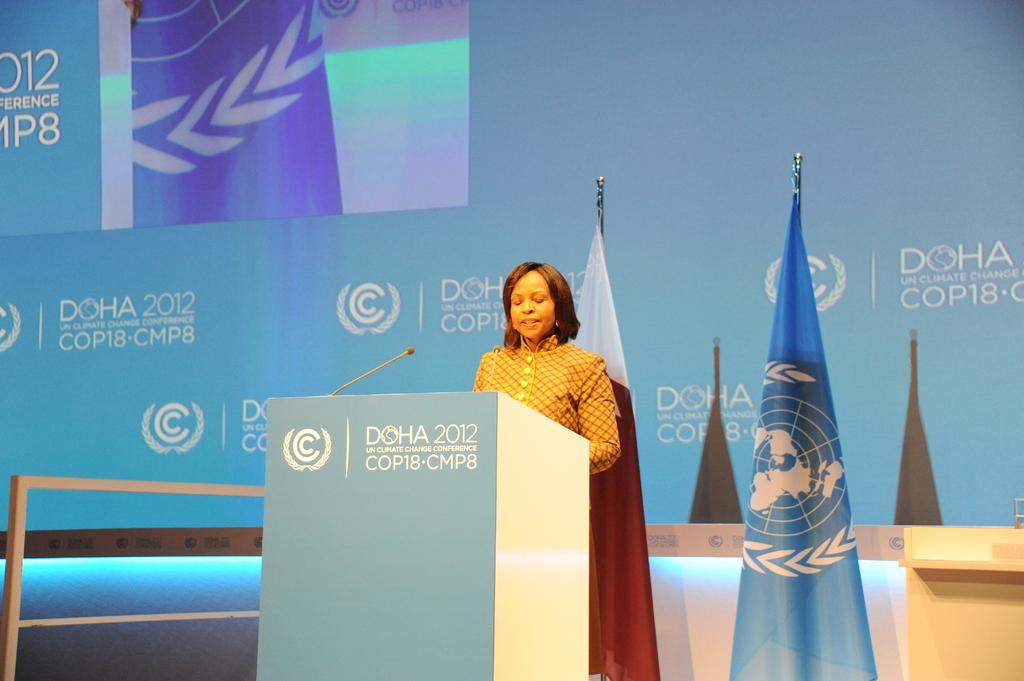What is the main subject of the image? There is a person in the image. What can be observed about the person's attire? The person is wearing clothes. Where is the person located in the image? The person is standing in front of a podium. What can be seen in the middle of the image? There are flags in the middle of the image. What is visible in the background of the image? There is text visible in the background of the image. What type of cherries is the person eating in the image? There are no cherries present in the image, and the person is not eating anything. How does the person's haircut look in the image? The person's haircut is not visible in the image, as their head is not shown. 